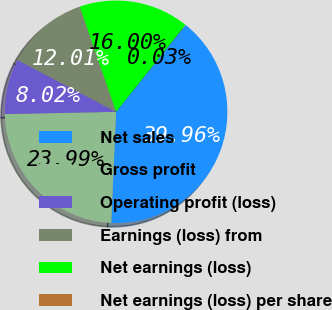<chart> <loc_0><loc_0><loc_500><loc_500><pie_chart><fcel>Net sales<fcel>Gross profit<fcel>Operating profit (loss)<fcel>Earnings (loss) from<fcel>Net earnings (loss)<fcel>Net earnings (loss) per share<nl><fcel>39.96%<fcel>23.99%<fcel>8.02%<fcel>12.01%<fcel>16.0%<fcel>0.03%<nl></chart> 